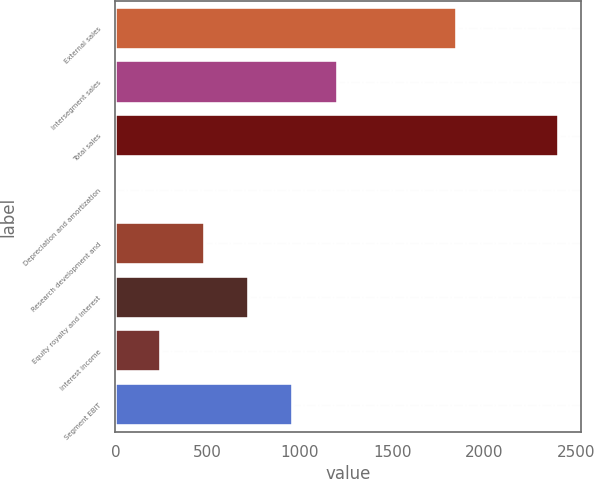Convert chart. <chart><loc_0><loc_0><loc_500><loc_500><bar_chart><fcel>External sales<fcel>Intersegment sales<fcel>Total sales<fcel>Depreciation and amortization<fcel>Research development and<fcel>Equity royalty and interest<fcel>Interest income<fcel>Segment EBIT<nl><fcel>1850<fcel>1205<fcel>2405<fcel>5<fcel>485<fcel>725<fcel>245<fcel>965<nl></chart> 